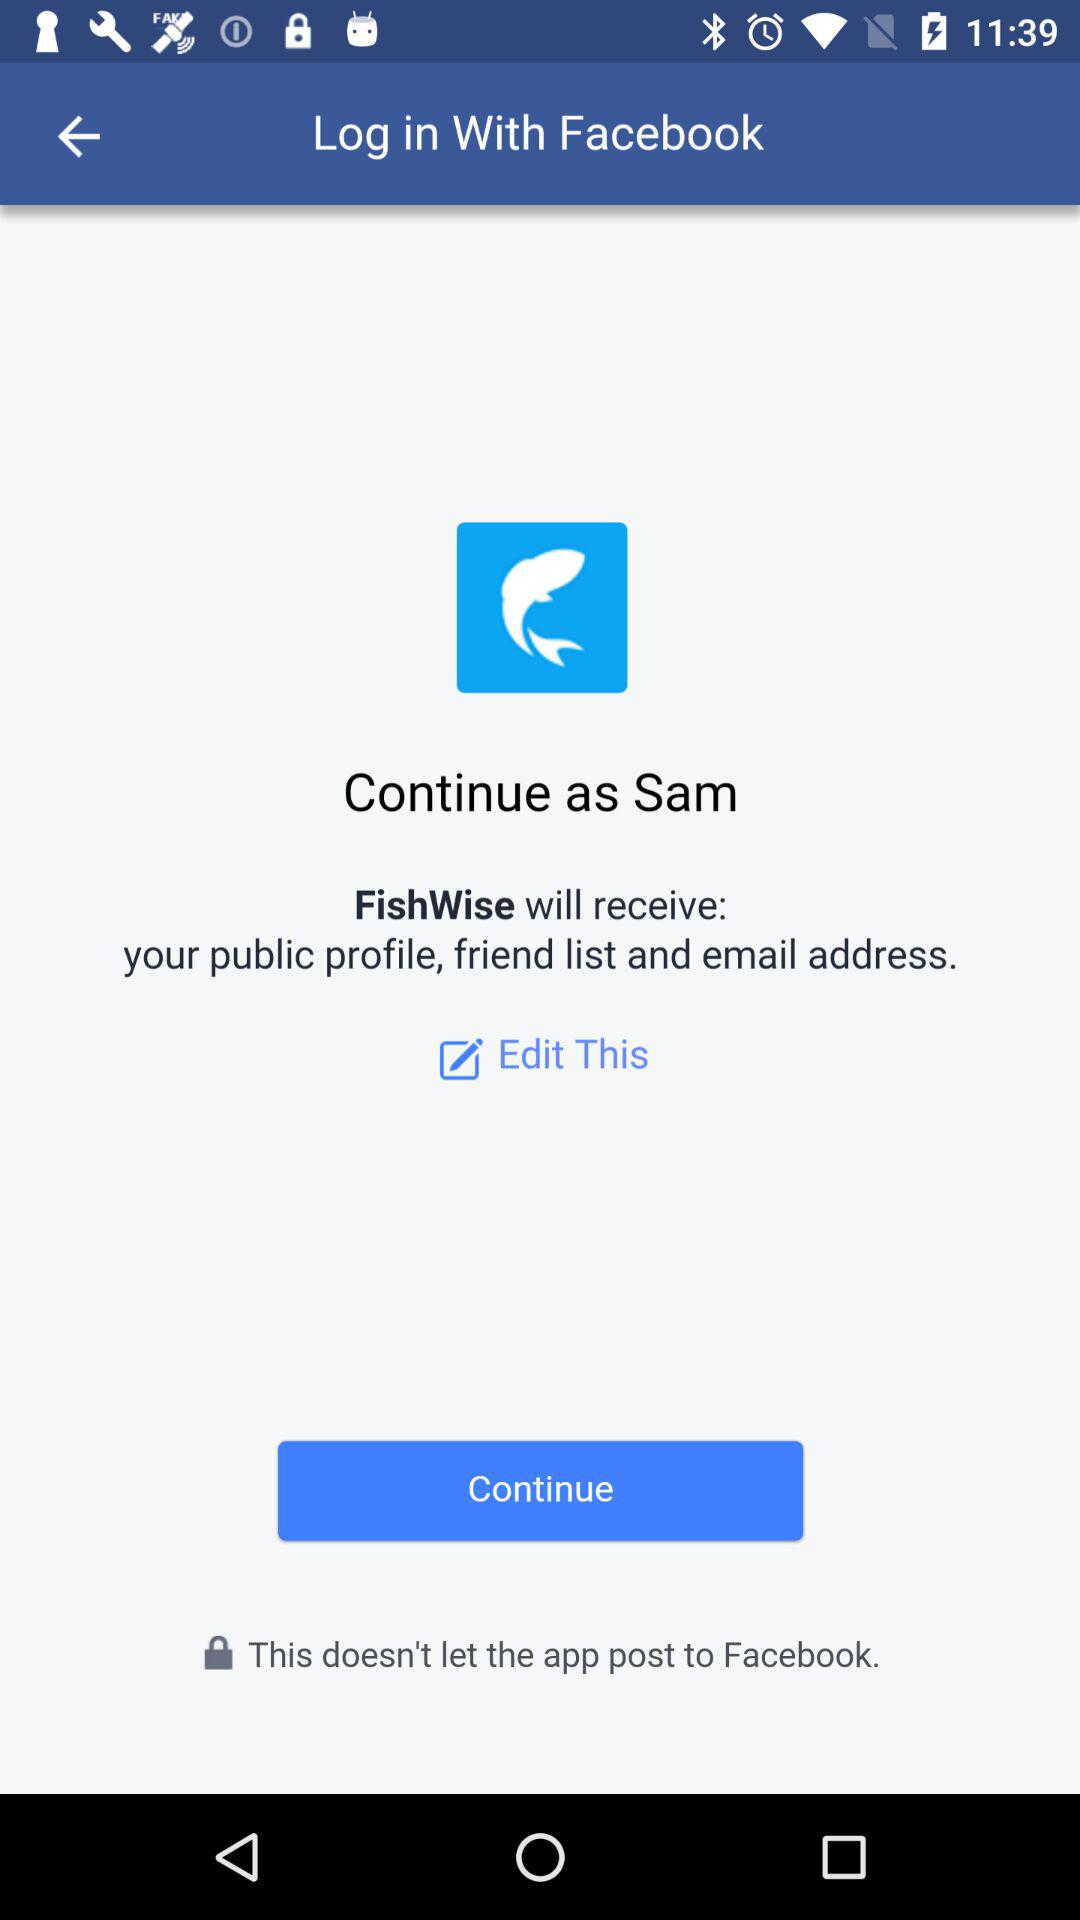What application is asking for permission? The application "FishWise" is asking for permission. 